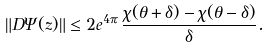Convert formula to latex. <formula><loc_0><loc_0><loc_500><loc_500>\| D \Psi ( z ) \| \leq 2 e ^ { 4 \pi } \, \frac { \chi ( \theta + \delta ) - \chi ( \theta - \delta ) } { \delta } .</formula> 